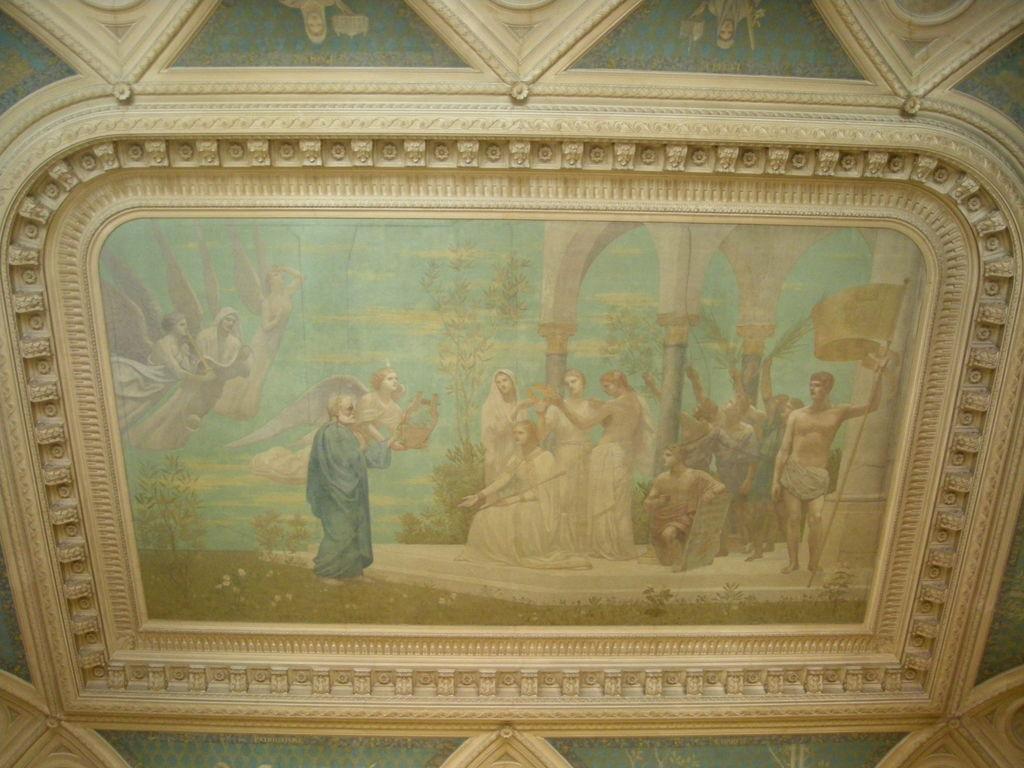In one or two sentences, can you explain what this image depicts? In this image on the wall there is a painting. In the painting there are many people, trees, water body is there. There are many designs on the wall. 